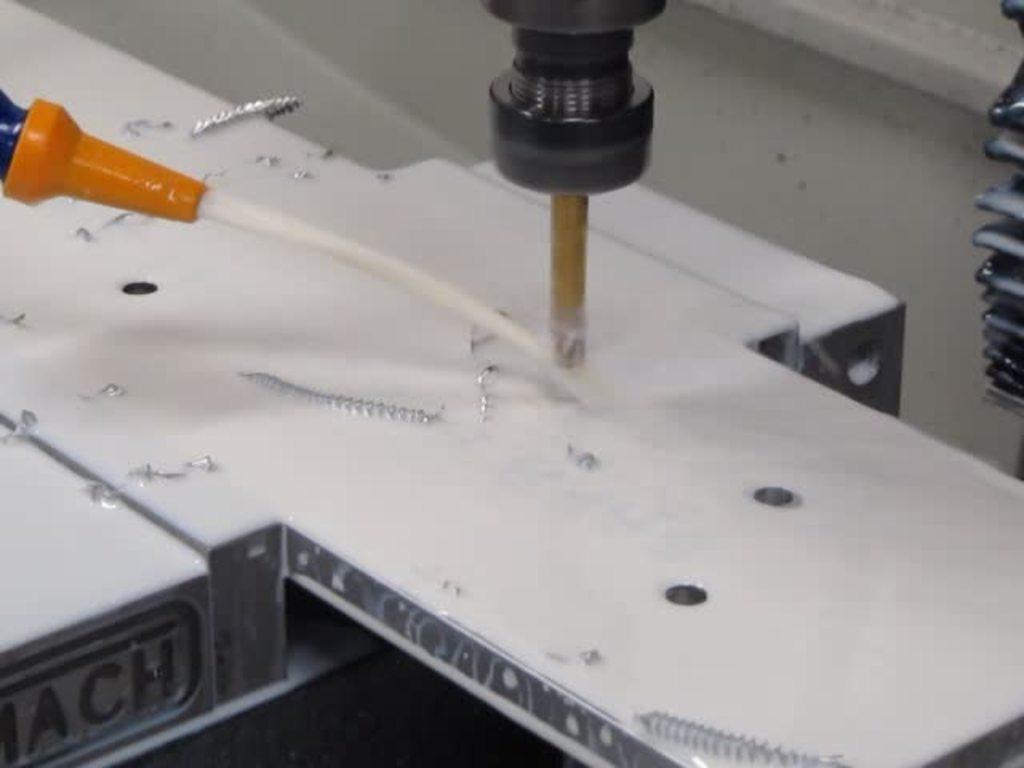In one or two sentences, can you explain what this image depicts? In the picture we can see a plank on it we can see a drilling machine which is drilling into the plank and we can also see some iron scrap around it. 